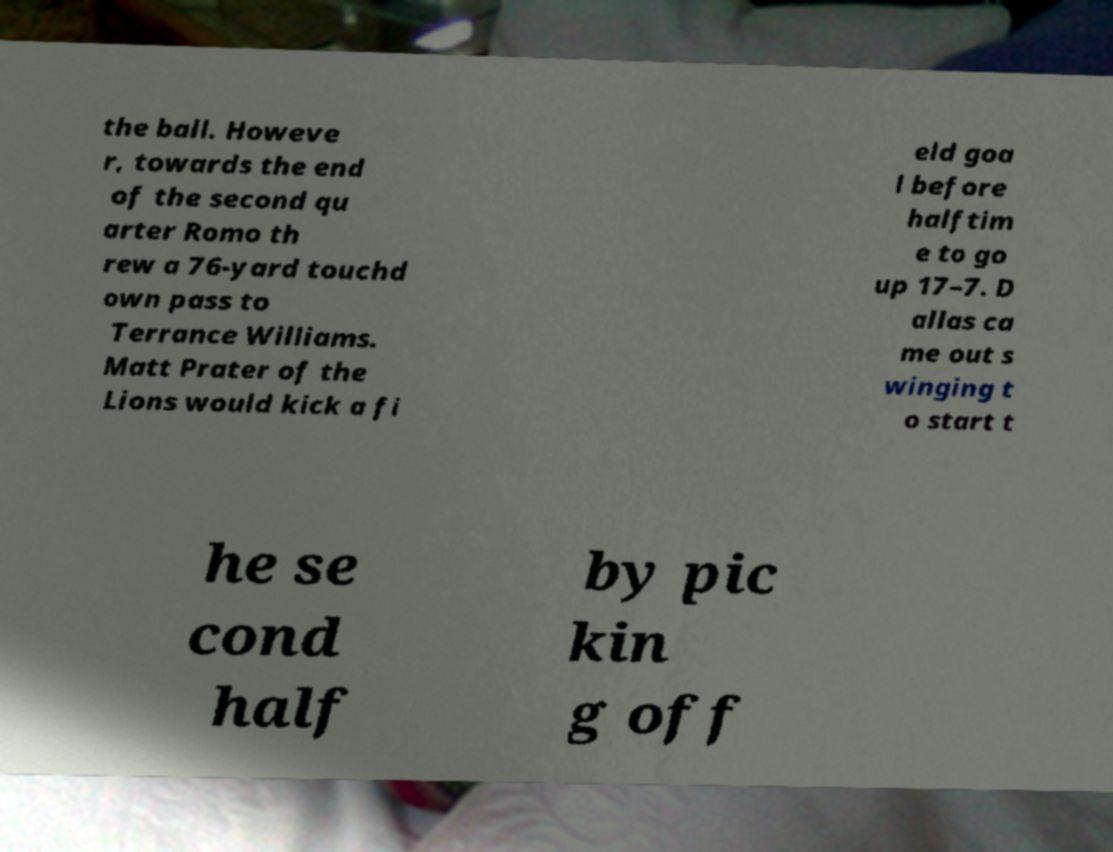There's text embedded in this image that I need extracted. Can you transcribe it verbatim? the ball. Howeve r, towards the end of the second qu arter Romo th rew a 76-yard touchd own pass to Terrance Williams. Matt Prater of the Lions would kick a fi eld goa l before halftim e to go up 17–7. D allas ca me out s winging t o start t he se cond half by pic kin g off 